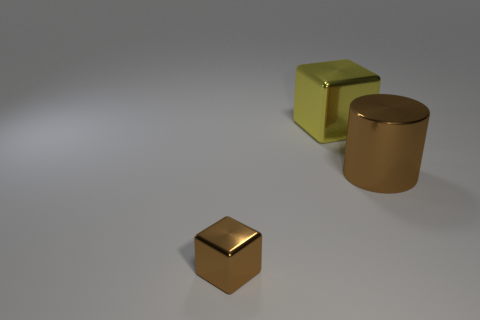How many large metal objects have the same color as the tiny shiny block?
Ensure brevity in your answer.  1. Is the number of big brown cylinders less than the number of big brown matte cylinders?
Your answer should be very brief. No. Do the brown cylinder and the big yellow thing have the same material?
Your answer should be very brief. Yes. How many other objects are the same size as the cylinder?
Give a very brief answer. 1. What is the color of the metal object behind the brown thing right of the small object?
Provide a succinct answer. Yellow. How many other objects are the same shape as the big brown object?
Your response must be concise. 0. Is there another brown cylinder that has the same material as the cylinder?
Your answer should be very brief. No. There is a brown cylinder that is the same size as the yellow thing; what is its material?
Offer a very short reply. Metal. What color is the metallic object right of the block behind the brown metal thing behind the tiny block?
Ensure brevity in your answer.  Brown. Is the shape of the brown metallic object that is on the right side of the yellow block the same as the object behind the large brown metal thing?
Give a very brief answer. No. 